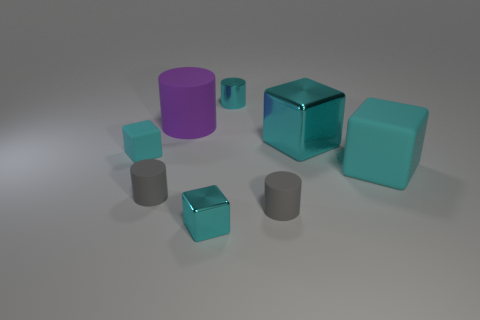Do the metallic cylinder and the purple rubber object have the same size?
Provide a short and direct response. No. What color is the rubber thing that is both behind the big rubber cube and on the left side of the purple matte cylinder?
Give a very brief answer. Cyan. There is a cyan thing to the left of the small gray matte object that is on the left side of the tiny cyan cylinder; what is its material?
Give a very brief answer. Rubber. There is another rubber object that is the same shape as the small cyan matte object; what size is it?
Your response must be concise. Large. Does the big block in front of the large cyan shiny block have the same color as the big matte cylinder?
Ensure brevity in your answer.  No. Is the number of big purple matte things less than the number of large red shiny balls?
Make the answer very short. No. How many other objects are there of the same color as the metallic cylinder?
Your answer should be compact. 4. Does the cyan block in front of the big cyan matte cube have the same material as the big cylinder?
Ensure brevity in your answer.  No. What material is the big object that is left of the big metal block?
Offer a very short reply. Rubber. What size is the gray cylinder on the left side of the metal cube in front of the small cyan rubber block?
Keep it short and to the point. Small. 